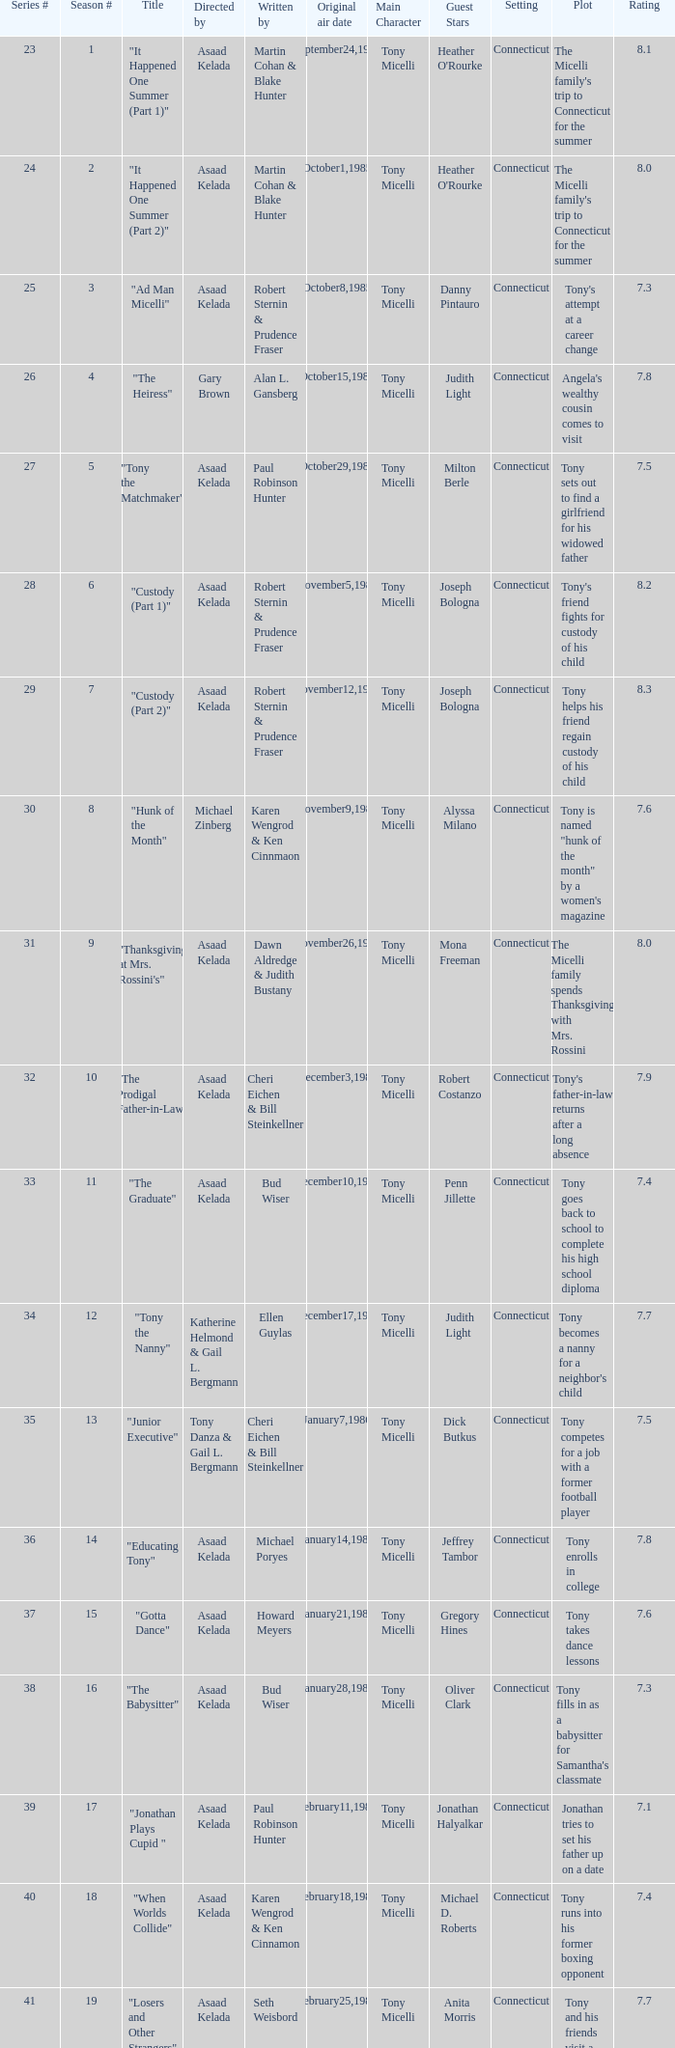What is the season where the episode "when worlds collide" was shown? 18.0. 